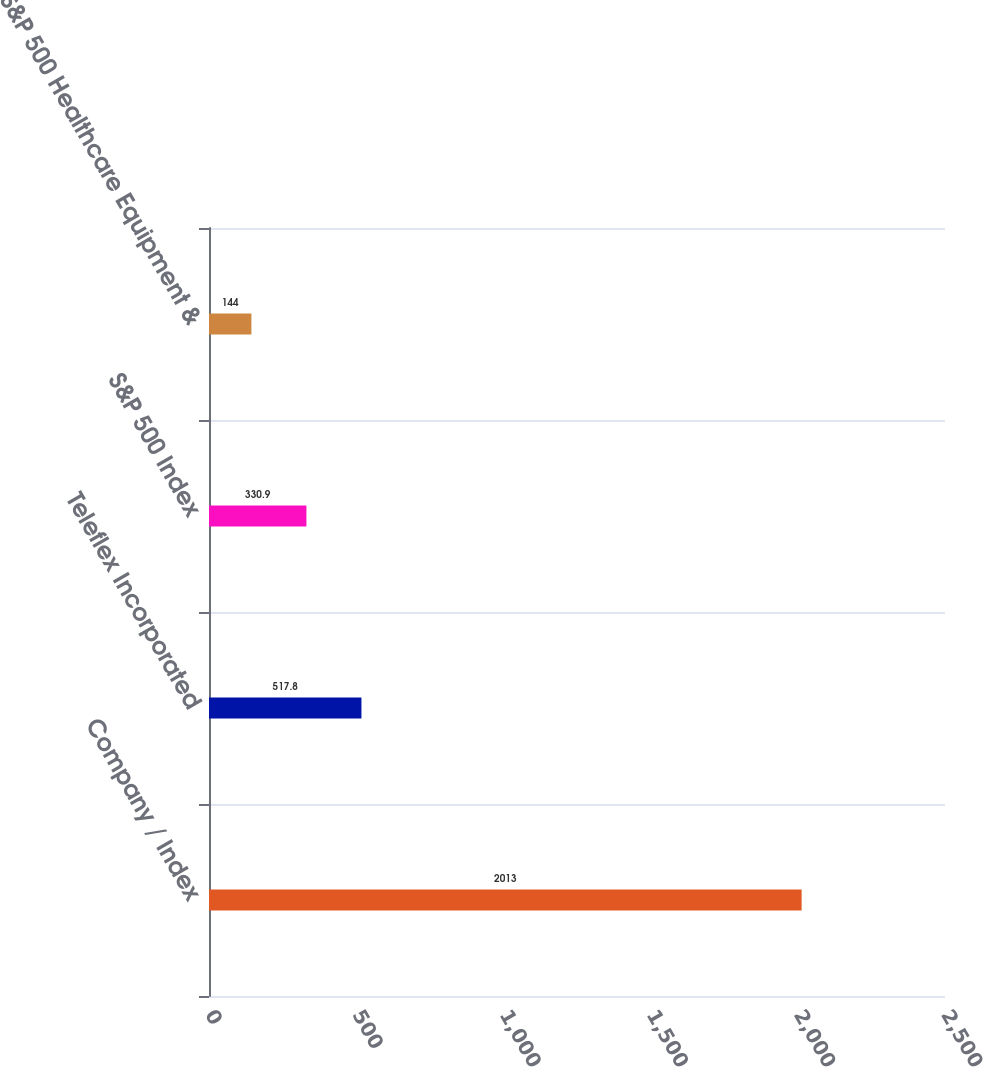Convert chart to OTSL. <chart><loc_0><loc_0><loc_500><loc_500><bar_chart><fcel>Company / Index<fcel>Teleflex Incorporated<fcel>S&P 500 Index<fcel>S&P 500 Healthcare Equipment &<nl><fcel>2013<fcel>517.8<fcel>330.9<fcel>144<nl></chart> 